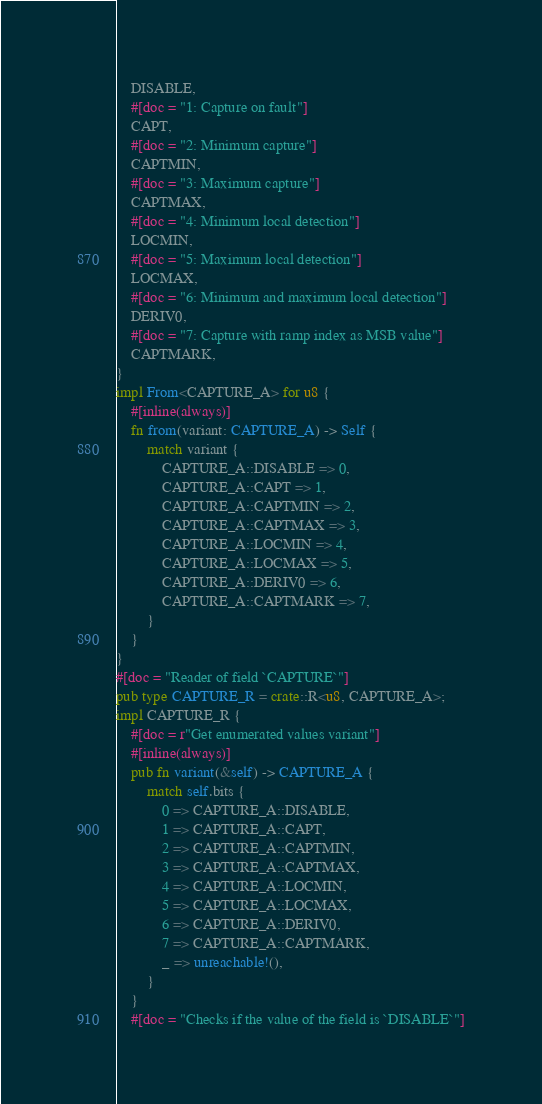<code> <loc_0><loc_0><loc_500><loc_500><_Rust_>    DISABLE,
    #[doc = "1: Capture on fault"]
    CAPT,
    #[doc = "2: Minimum capture"]
    CAPTMIN,
    #[doc = "3: Maximum capture"]
    CAPTMAX,
    #[doc = "4: Minimum local detection"]
    LOCMIN,
    #[doc = "5: Maximum local detection"]
    LOCMAX,
    #[doc = "6: Minimum and maximum local detection"]
    DERIV0,
    #[doc = "7: Capture with ramp index as MSB value"]
    CAPTMARK,
}
impl From<CAPTURE_A> for u8 {
    #[inline(always)]
    fn from(variant: CAPTURE_A) -> Self {
        match variant {
            CAPTURE_A::DISABLE => 0,
            CAPTURE_A::CAPT => 1,
            CAPTURE_A::CAPTMIN => 2,
            CAPTURE_A::CAPTMAX => 3,
            CAPTURE_A::LOCMIN => 4,
            CAPTURE_A::LOCMAX => 5,
            CAPTURE_A::DERIV0 => 6,
            CAPTURE_A::CAPTMARK => 7,
        }
    }
}
#[doc = "Reader of field `CAPTURE`"]
pub type CAPTURE_R = crate::R<u8, CAPTURE_A>;
impl CAPTURE_R {
    #[doc = r"Get enumerated values variant"]
    #[inline(always)]
    pub fn variant(&self) -> CAPTURE_A {
        match self.bits {
            0 => CAPTURE_A::DISABLE,
            1 => CAPTURE_A::CAPT,
            2 => CAPTURE_A::CAPTMIN,
            3 => CAPTURE_A::CAPTMAX,
            4 => CAPTURE_A::LOCMIN,
            5 => CAPTURE_A::LOCMAX,
            6 => CAPTURE_A::DERIV0,
            7 => CAPTURE_A::CAPTMARK,
            _ => unreachable!(),
        }
    }
    #[doc = "Checks if the value of the field is `DISABLE`"]</code> 